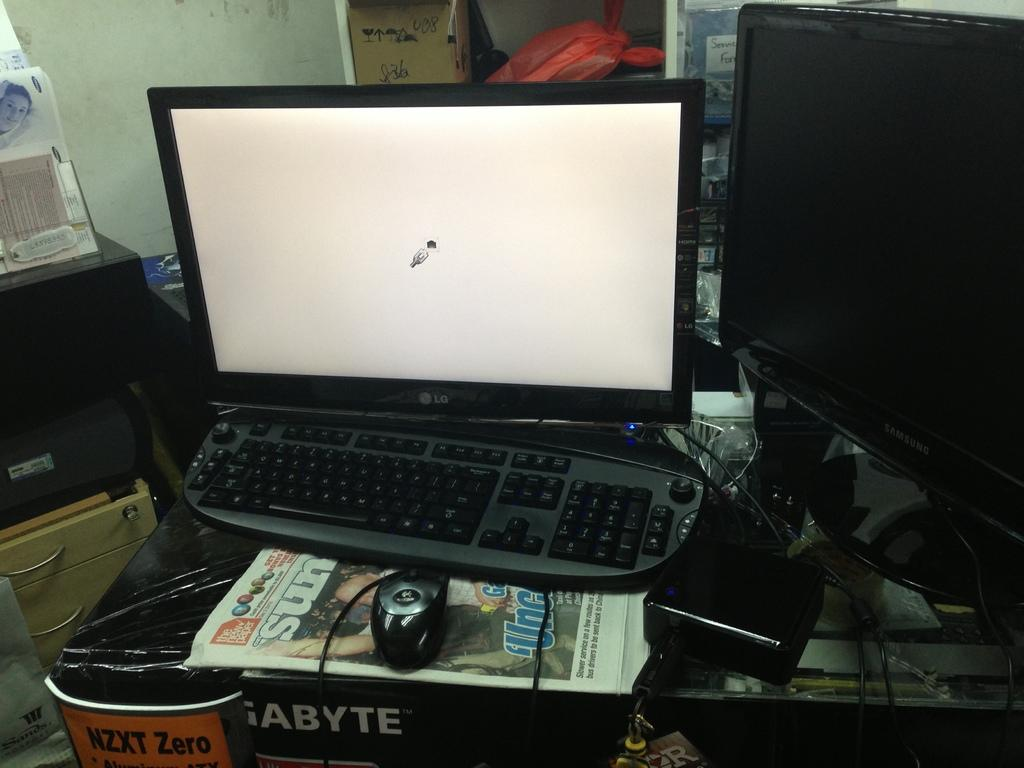<image>
Describe the image concisely. A computer sits on top of the Sundays's newspaper 